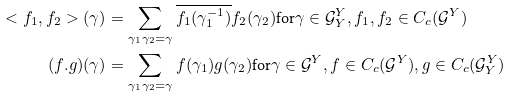Convert formula to latex. <formula><loc_0><loc_0><loc_500><loc_500>< f _ { 1 } , f _ { 2 } > ( \gamma ) & = \sum _ { \gamma _ { 1 } \gamma _ { 2 } = \gamma } \overline { f _ { 1 } ( \gamma _ { 1 } ^ { - 1 } ) } f _ { 2 } ( \gamma _ { 2 } ) \text {for} \gamma \in \mathcal { G } ^ { Y } _ { Y } , f _ { 1 } , f _ { 2 } \in C _ { c } ( \mathcal { G } ^ { Y } ) \\ ( f . g ) ( \gamma ) & = \sum _ { \gamma _ { 1 } \gamma _ { 2 } = \gamma } f ( \gamma _ { 1 } ) g ( \gamma _ { 2 } ) \text {for} \gamma \in \mathcal { G } ^ { Y } , f \in C _ { c } ( \mathcal { G } ^ { Y } ) , g \in C _ { c } ( \mathcal { G } _ { Y } ^ { Y } )</formula> 